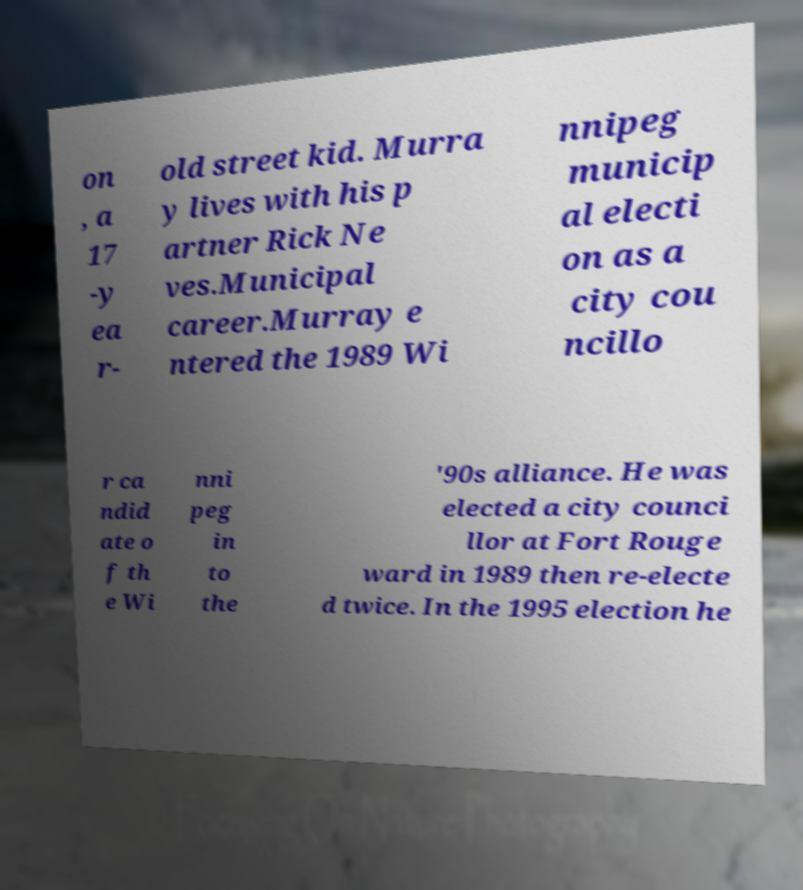Can you accurately transcribe the text from the provided image for me? on , a 17 -y ea r- old street kid. Murra y lives with his p artner Rick Ne ves.Municipal career.Murray e ntered the 1989 Wi nnipeg municip al electi on as a city cou ncillo r ca ndid ate o f th e Wi nni peg in to the '90s alliance. He was elected a city counci llor at Fort Rouge ward in 1989 then re-electe d twice. In the 1995 election he 